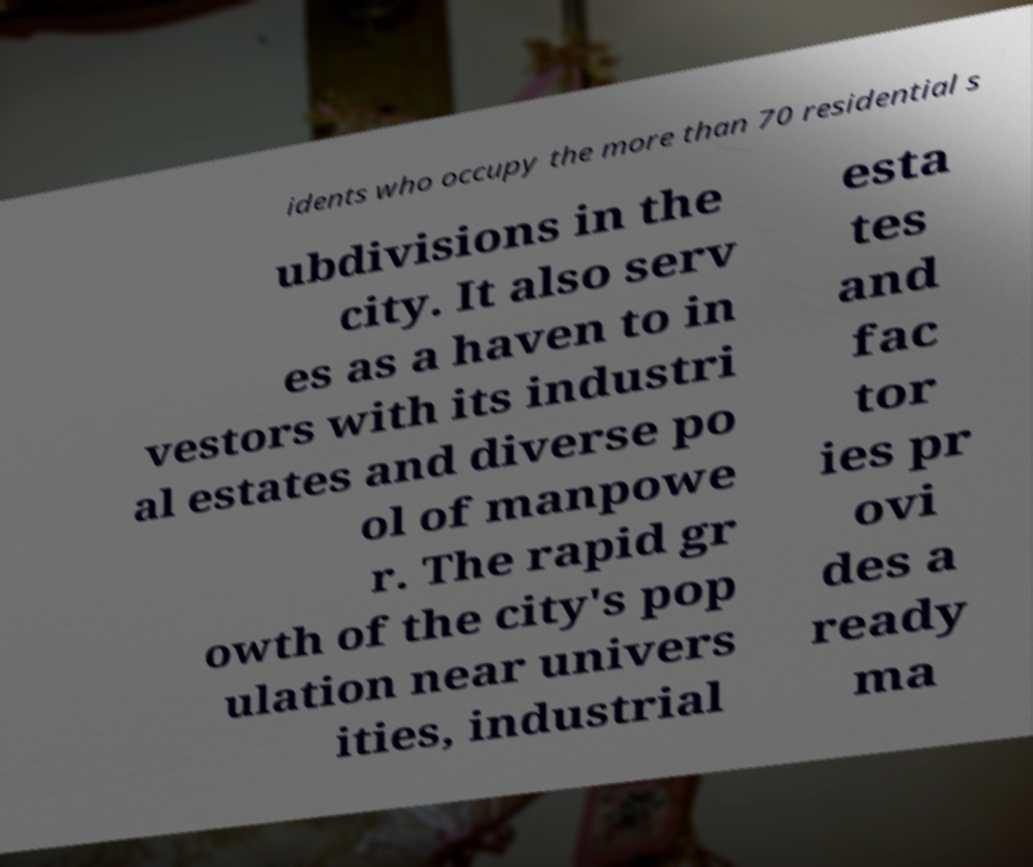What messages or text are displayed in this image? I need them in a readable, typed format. idents who occupy the more than 70 residential s ubdivisions in the city. It also serv es as a haven to in vestors with its industri al estates and diverse po ol of manpowe r. The rapid gr owth of the city's pop ulation near univers ities, industrial esta tes and fac tor ies pr ovi des a ready ma 